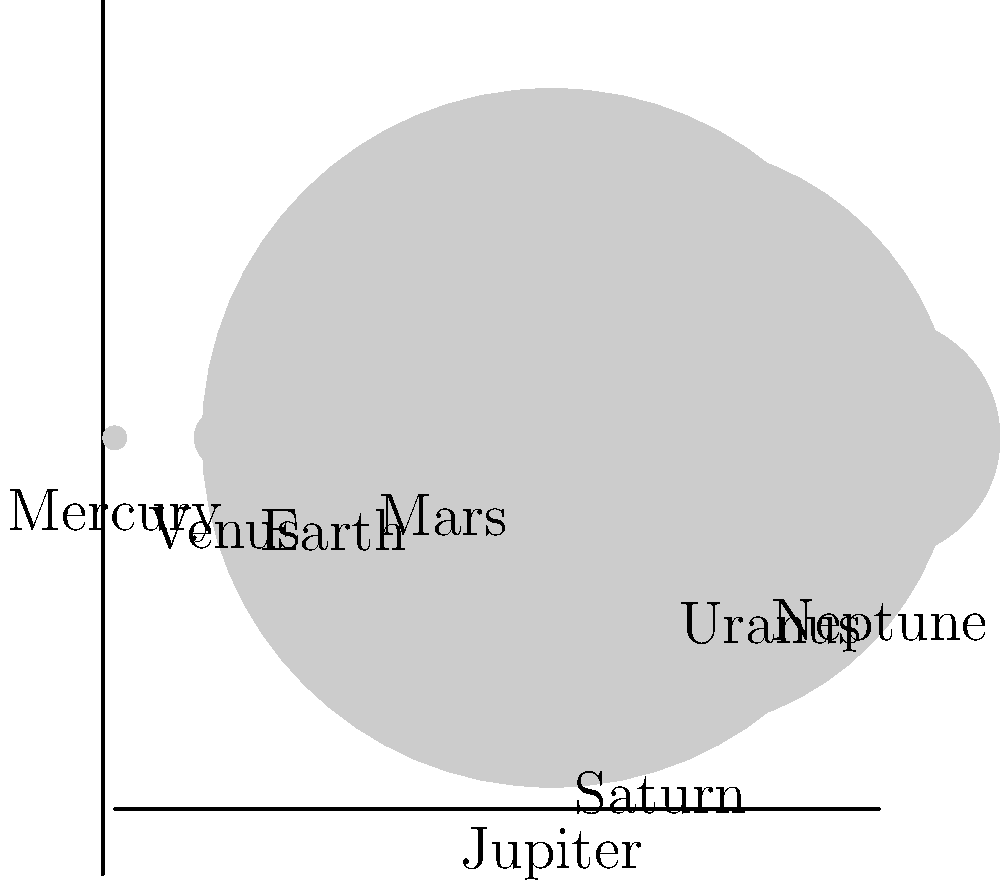As a restaurant owner offering recommendations for local attractions, you might be asked about stargazing opportunities. To prepare, you're brushing up on your astronomy knowledge. Looking at the diagram of relative planet sizes, which planet is closest in size to Earth? To answer this question, we need to follow these steps:

1. Identify Earth in the diagram: Earth is labeled and shown as the third planet from the left.

2. Observe the sizes of the planets: The diagram shows the relative sizes of the planets in our solar system, with each planet represented by a circle.

3. Compare Earth's size to other planets:
   - Mercury and Mars are noticeably smaller than Earth.
   - Jupiter and Saturn are much larger than Earth.
   - Uranus and Neptune are also larger than Earth, but not as large as Jupiter and Saturn.
   - Venus appears to be very close in size to Earth.

4. Conclude: By visual comparison, Venus is the planet that appears closest in size to Earth.

This aligns with astronomical data:
- Earth's diameter: 12,756 km
- Venus's diameter: 12,104 km

The difference is only about 5%, making Venus the planet closest in size to Earth in our solar system.
Answer: Venus 